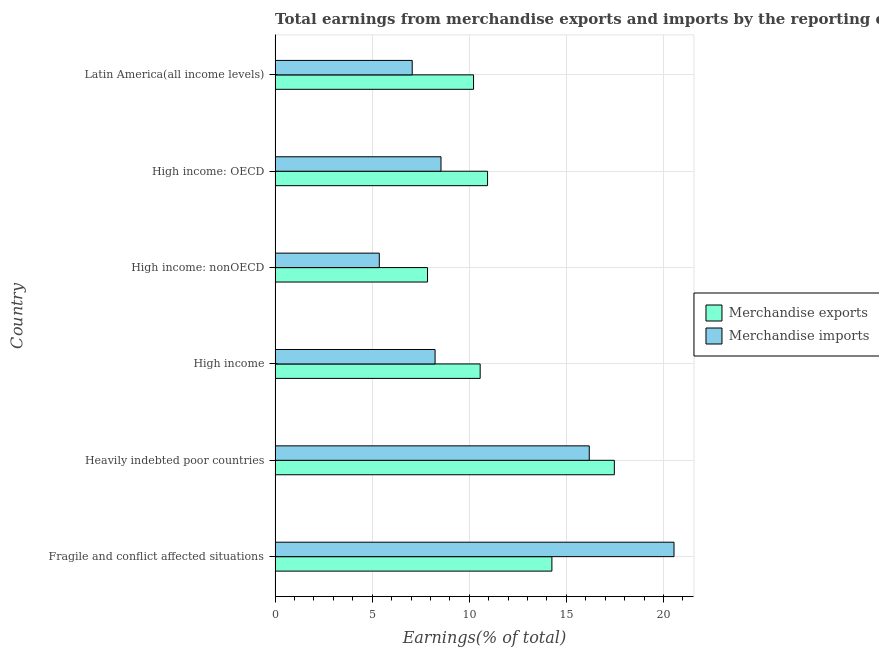How many different coloured bars are there?
Your answer should be very brief. 2. What is the label of the 1st group of bars from the top?
Give a very brief answer. Latin America(all income levels). What is the earnings from merchandise imports in Heavily indebted poor countries?
Provide a succinct answer. 16.18. Across all countries, what is the maximum earnings from merchandise exports?
Your response must be concise. 17.47. Across all countries, what is the minimum earnings from merchandise imports?
Provide a short and direct response. 5.37. In which country was the earnings from merchandise imports maximum?
Your response must be concise. Fragile and conflict affected situations. In which country was the earnings from merchandise imports minimum?
Offer a terse response. High income: nonOECD. What is the total earnings from merchandise exports in the graph?
Offer a very short reply. 71.29. What is the difference between the earnings from merchandise imports in High income: nonOECD and that in Latin America(all income levels)?
Provide a succinct answer. -1.7. What is the difference between the earnings from merchandise exports in High income: OECD and the earnings from merchandise imports in Heavily indebted poor countries?
Offer a terse response. -5.24. What is the average earnings from merchandise imports per country?
Provide a succinct answer. 10.99. What is the difference between the earnings from merchandise imports and earnings from merchandise exports in Latin America(all income levels)?
Ensure brevity in your answer.  -3.16. What is the ratio of the earnings from merchandise exports in High income: OECD to that in Latin America(all income levels)?
Offer a terse response. 1.07. Is the earnings from merchandise exports in Fragile and conflict affected situations less than that in High income: OECD?
Ensure brevity in your answer.  No. What is the difference between the highest and the second highest earnings from merchandise exports?
Provide a succinct answer. 3.22. What is the difference between the highest and the lowest earnings from merchandise imports?
Offer a terse response. 15.18. What does the 1st bar from the top in High income represents?
Make the answer very short. Merchandise imports. How many countries are there in the graph?
Your answer should be very brief. 6. What is the difference between two consecutive major ticks on the X-axis?
Ensure brevity in your answer.  5. Are the values on the major ticks of X-axis written in scientific E-notation?
Provide a short and direct response. No. Does the graph contain any zero values?
Provide a short and direct response. No. Where does the legend appear in the graph?
Make the answer very short. Center right. How many legend labels are there?
Your response must be concise. 2. What is the title of the graph?
Give a very brief answer. Total earnings from merchandise exports and imports by the reporting economy(residual) in 1978. What is the label or title of the X-axis?
Offer a terse response. Earnings(% of total). What is the label or title of the Y-axis?
Your answer should be very brief. Country. What is the Earnings(% of total) of Merchandise exports in Fragile and conflict affected situations?
Provide a short and direct response. 14.25. What is the Earnings(% of total) in Merchandise imports in Fragile and conflict affected situations?
Give a very brief answer. 20.54. What is the Earnings(% of total) of Merchandise exports in Heavily indebted poor countries?
Provide a short and direct response. 17.47. What is the Earnings(% of total) in Merchandise imports in Heavily indebted poor countries?
Keep it short and to the point. 16.18. What is the Earnings(% of total) of Merchandise exports in High income?
Make the answer very short. 10.56. What is the Earnings(% of total) in Merchandise imports in High income?
Give a very brief answer. 8.24. What is the Earnings(% of total) of Merchandise exports in High income: nonOECD?
Offer a terse response. 7.85. What is the Earnings(% of total) of Merchandise imports in High income: nonOECD?
Make the answer very short. 5.37. What is the Earnings(% of total) of Merchandise exports in High income: OECD?
Make the answer very short. 10.94. What is the Earnings(% of total) in Merchandise imports in High income: OECD?
Offer a very short reply. 8.54. What is the Earnings(% of total) in Merchandise exports in Latin America(all income levels)?
Provide a short and direct response. 10.22. What is the Earnings(% of total) in Merchandise imports in Latin America(all income levels)?
Your response must be concise. 7.06. Across all countries, what is the maximum Earnings(% of total) of Merchandise exports?
Your answer should be very brief. 17.47. Across all countries, what is the maximum Earnings(% of total) of Merchandise imports?
Give a very brief answer. 20.54. Across all countries, what is the minimum Earnings(% of total) of Merchandise exports?
Your response must be concise. 7.85. Across all countries, what is the minimum Earnings(% of total) of Merchandise imports?
Ensure brevity in your answer.  5.37. What is the total Earnings(% of total) in Merchandise exports in the graph?
Provide a short and direct response. 71.3. What is the total Earnings(% of total) in Merchandise imports in the graph?
Offer a terse response. 65.93. What is the difference between the Earnings(% of total) in Merchandise exports in Fragile and conflict affected situations and that in Heavily indebted poor countries?
Give a very brief answer. -3.22. What is the difference between the Earnings(% of total) of Merchandise imports in Fragile and conflict affected situations and that in Heavily indebted poor countries?
Your answer should be very brief. 4.36. What is the difference between the Earnings(% of total) in Merchandise exports in Fragile and conflict affected situations and that in High income?
Your response must be concise. 3.69. What is the difference between the Earnings(% of total) in Merchandise imports in Fragile and conflict affected situations and that in High income?
Offer a very short reply. 12.3. What is the difference between the Earnings(% of total) in Merchandise exports in Fragile and conflict affected situations and that in High income: nonOECD?
Your answer should be very brief. 6.4. What is the difference between the Earnings(% of total) of Merchandise imports in Fragile and conflict affected situations and that in High income: nonOECD?
Make the answer very short. 15.18. What is the difference between the Earnings(% of total) of Merchandise exports in Fragile and conflict affected situations and that in High income: OECD?
Provide a short and direct response. 3.31. What is the difference between the Earnings(% of total) of Merchandise imports in Fragile and conflict affected situations and that in High income: OECD?
Your answer should be compact. 12. What is the difference between the Earnings(% of total) of Merchandise exports in Fragile and conflict affected situations and that in Latin America(all income levels)?
Provide a short and direct response. 4.03. What is the difference between the Earnings(% of total) of Merchandise imports in Fragile and conflict affected situations and that in Latin America(all income levels)?
Your response must be concise. 13.48. What is the difference between the Earnings(% of total) of Merchandise exports in Heavily indebted poor countries and that in High income?
Your response must be concise. 6.91. What is the difference between the Earnings(% of total) of Merchandise imports in Heavily indebted poor countries and that in High income?
Offer a very short reply. 7.94. What is the difference between the Earnings(% of total) of Merchandise exports in Heavily indebted poor countries and that in High income: nonOECD?
Offer a terse response. 9.62. What is the difference between the Earnings(% of total) of Merchandise imports in Heavily indebted poor countries and that in High income: nonOECD?
Provide a short and direct response. 10.81. What is the difference between the Earnings(% of total) of Merchandise exports in Heavily indebted poor countries and that in High income: OECD?
Your answer should be compact. 6.53. What is the difference between the Earnings(% of total) in Merchandise imports in Heavily indebted poor countries and that in High income: OECD?
Provide a short and direct response. 7.63. What is the difference between the Earnings(% of total) of Merchandise exports in Heavily indebted poor countries and that in Latin America(all income levels)?
Provide a short and direct response. 7.25. What is the difference between the Earnings(% of total) of Merchandise imports in Heavily indebted poor countries and that in Latin America(all income levels)?
Make the answer very short. 9.12. What is the difference between the Earnings(% of total) in Merchandise exports in High income and that in High income: nonOECD?
Your answer should be very brief. 2.71. What is the difference between the Earnings(% of total) in Merchandise imports in High income and that in High income: nonOECD?
Make the answer very short. 2.87. What is the difference between the Earnings(% of total) in Merchandise exports in High income and that in High income: OECD?
Give a very brief answer. -0.38. What is the difference between the Earnings(% of total) in Merchandise imports in High income and that in High income: OECD?
Keep it short and to the point. -0.3. What is the difference between the Earnings(% of total) of Merchandise exports in High income and that in Latin America(all income levels)?
Give a very brief answer. 0.34. What is the difference between the Earnings(% of total) in Merchandise imports in High income and that in Latin America(all income levels)?
Offer a terse response. 1.18. What is the difference between the Earnings(% of total) of Merchandise exports in High income: nonOECD and that in High income: OECD?
Offer a terse response. -3.09. What is the difference between the Earnings(% of total) of Merchandise imports in High income: nonOECD and that in High income: OECD?
Make the answer very short. -3.18. What is the difference between the Earnings(% of total) in Merchandise exports in High income: nonOECD and that in Latin America(all income levels)?
Provide a short and direct response. -2.37. What is the difference between the Earnings(% of total) in Merchandise imports in High income: nonOECD and that in Latin America(all income levels)?
Keep it short and to the point. -1.7. What is the difference between the Earnings(% of total) in Merchandise exports in High income: OECD and that in Latin America(all income levels)?
Provide a short and direct response. 0.72. What is the difference between the Earnings(% of total) in Merchandise imports in High income: OECD and that in Latin America(all income levels)?
Your response must be concise. 1.48. What is the difference between the Earnings(% of total) of Merchandise exports in Fragile and conflict affected situations and the Earnings(% of total) of Merchandise imports in Heavily indebted poor countries?
Your response must be concise. -1.92. What is the difference between the Earnings(% of total) of Merchandise exports in Fragile and conflict affected situations and the Earnings(% of total) of Merchandise imports in High income?
Keep it short and to the point. 6.01. What is the difference between the Earnings(% of total) of Merchandise exports in Fragile and conflict affected situations and the Earnings(% of total) of Merchandise imports in High income: nonOECD?
Your answer should be compact. 8.89. What is the difference between the Earnings(% of total) of Merchandise exports in Fragile and conflict affected situations and the Earnings(% of total) of Merchandise imports in High income: OECD?
Offer a terse response. 5.71. What is the difference between the Earnings(% of total) in Merchandise exports in Fragile and conflict affected situations and the Earnings(% of total) in Merchandise imports in Latin America(all income levels)?
Give a very brief answer. 7.19. What is the difference between the Earnings(% of total) in Merchandise exports in Heavily indebted poor countries and the Earnings(% of total) in Merchandise imports in High income?
Offer a very short reply. 9.23. What is the difference between the Earnings(% of total) of Merchandise exports in Heavily indebted poor countries and the Earnings(% of total) of Merchandise imports in High income: nonOECD?
Give a very brief answer. 12.1. What is the difference between the Earnings(% of total) in Merchandise exports in Heavily indebted poor countries and the Earnings(% of total) in Merchandise imports in High income: OECD?
Ensure brevity in your answer.  8.93. What is the difference between the Earnings(% of total) in Merchandise exports in Heavily indebted poor countries and the Earnings(% of total) in Merchandise imports in Latin America(all income levels)?
Offer a terse response. 10.41. What is the difference between the Earnings(% of total) of Merchandise exports in High income and the Earnings(% of total) of Merchandise imports in High income: nonOECD?
Offer a terse response. 5.19. What is the difference between the Earnings(% of total) in Merchandise exports in High income and the Earnings(% of total) in Merchandise imports in High income: OECD?
Make the answer very short. 2.02. What is the difference between the Earnings(% of total) of Merchandise exports in High income and the Earnings(% of total) of Merchandise imports in Latin America(all income levels)?
Offer a terse response. 3.5. What is the difference between the Earnings(% of total) of Merchandise exports in High income: nonOECD and the Earnings(% of total) of Merchandise imports in High income: OECD?
Your response must be concise. -0.69. What is the difference between the Earnings(% of total) in Merchandise exports in High income: nonOECD and the Earnings(% of total) in Merchandise imports in Latin America(all income levels)?
Offer a very short reply. 0.79. What is the difference between the Earnings(% of total) of Merchandise exports in High income: OECD and the Earnings(% of total) of Merchandise imports in Latin America(all income levels)?
Offer a terse response. 3.88. What is the average Earnings(% of total) of Merchandise exports per country?
Your response must be concise. 11.88. What is the average Earnings(% of total) in Merchandise imports per country?
Offer a terse response. 10.99. What is the difference between the Earnings(% of total) in Merchandise exports and Earnings(% of total) in Merchandise imports in Fragile and conflict affected situations?
Keep it short and to the point. -6.29. What is the difference between the Earnings(% of total) of Merchandise exports and Earnings(% of total) of Merchandise imports in Heavily indebted poor countries?
Make the answer very short. 1.29. What is the difference between the Earnings(% of total) in Merchandise exports and Earnings(% of total) in Merchandise imports in High income?
Make the answer very short. 2.32. What is the difference between the Earnings(% of total) of Merchandise exports and Earnings(% of total) of Merchandise imports in High income: nonOECD?
Offer a terse response. 2.48. What is the difference between the Earnings(% of total) of Merchandise exports and Earnings(% of total) of Merchandise imports in High income: OECD?
Make the answer very short. 2.4. What is the difference between the Earnings(% of total) in Merchandise exports and Earnings(% of total) in Merchandise imports in Latin America(all income levels)?
Provide a succinct answer. 3.16. What is the ratio of the Earnings(% of total) of Merchandise exports in Fragile and conflict affected situations to that in Heavily indebted poor countries?
Keep it short and to the point. 0.82. What is the ratio of the Earnings(% of total) of Merchandise imports in Fragile and conflict affected situations to that in Heavily indebted poor countries?
Make the answer very short. 1.27. What is the ratio of the Earnings(% of total) in Merchandise exports in Fragile and conflict affected situations to that in High income?
Your answer should be very brief. 1.35. What is the ratio of the Earnings(% of total) of Merchandise imports in Fragile and conflict affected situations to that in High income?
Offer a very short reply. 2.49. What is the ratio of the Earnings(% of total) in Merchandise exports in Fragile and conflict affected situations to that in High income: nonOECD?
Keep it short and to the point. 1.82. What is the ratio of the Earnings(% of total) in Merchandise imports in Fragile and conflict affected situations to that in High income: nonOECD?
Keep it short and to the point. 3.83. What is the ratio of the Earnings(% of total) in Merchandise exports in Fragile and conflict affected situations to that in High income: OECD?
Your response must be concise. 1.3. What is the ratio of the Earnings(% of total) of Merchandise imports in Fragile and conflict affected situations to that in High income: OECD?
Your answer should be compact. 2.4. What is the ratio of the Earnings(% of total) in Merchandise exports in Fragile and conflict affected situations to that in Latin America(all income levels)?
Provide a short and direct response. 1.39. What is the ratio of the Earnings(% of total) in Merchandise imports in Fragile and conflict affected situations to that in Latin America(all income levels)?
Your answer should be very brief. 2.91. What is the ratio of the Earnings(% of total) of Merchandise exports in Heavily indebted poor countries to that in High income?
Your answer should be very brief. 1.65. What is the ratio of the Earnings(% of total) in Merchandise imports in Heavily indebted poor countries to that in High income?
Provide a short and direct response. 1.96. What is the ratio of the Earnings(% of total) in Merchandise exports in Heavily indebted poor countries to that in High income: nonOECD?
Provide a succinct answer. 2.23. What is the ratio of the Earnings(% of total) in Merchandise imports in Heavily indebted poor countries to that in High income: nonOECD?
Provide a short and direct response. 3.01. What is the ratio of the Earnings(% of total) in Merchandise exports in Heavily indebted poor countries to that in High income: OECD?
Your answer should be compact. 1.6. What is the ratio of the Earnings(% of total) in Merchandise imports in Heavily indebted poor countries to that in High income: OECD?
Your answer should be very brief. 1.89. What is the ratio of the Earnings(% of total) in Merchandise exports in Heavily indebted poor countries to that in Latin America(all income levels)?
Your answer should be compact. 1.71. What is the ratio of the Earnings(% of total) in Merchandise imports in Heavily indebted poor countries to that in Latin America(all income levels)?
Offer a very short reply. 2.29. What is the ratio of the Earnings(% of total) of Merchandise exports in High income to that in High income: nonOECD?
Give a very brief answer. 1.35. What is the ratio of the Earnings(% of total) of Merchandise imports in High income to that in High income: nonOECD?
Your response must be concise. 1.54. What is the ratio of the Earnings(% of total) of Merchandise exports in High income to that in High income: OECD?
Keep it short and to the point. 0.97. What is the ratio of the Earnings(% of total) in Merchandise exports in High income to that in Latin America(all income levels)?
Provide a short and direct response. 1.03. What is the ratio of the Earnings(% of total) in Merchandise exports in High income: nonOECD to that in High income: OECD?
Ensure brevity in your answer.  0.72. What is the ratio of the Earnings(% of total) of Merchandise imports in High income: nonOECD to that in High income: OECD?
Provide a short and direct response. 0.63. What is the ratio of the Earnings(% of total) in Merchandise exports in High income: nonOECD to that in Latin America(all income levels)?
Offer a terse response. 0.77. What is the ratio of the Earnings(% of total) of Merchandise imports in High income: nonOECD to that in Latin America(all income levels)?
Your response must be concise. 0.76. What is the ratio of the Earnings(% of total) of Merchandise exports in High income: OECD to that in Latin America(all income levels)?
Provide a succinct answer. 1.07. What is the ratio of the Earnings(% of total) in Merchandise imports in High income: OECD to that in Latin America(all income levels)?
Your answer should be compact. 1.21. What is the difference between the highest and the second highest Earnings(% of total) in Merchandise exports?
Offer a terse response. 3.22. What is the difference between the highest and the second highest Earnings(% of total) of Merchandise imports?
Provide a succinct answer. 4.36. What is the difference between the highest and the lowest Earnings(% of total) in Merchandise exports?
Your answer should be compact. 9.62. What is the difference between the highest and the lowest Earnings(% of total) of Merchandise imports?
Offer a terse response. 15.18. 